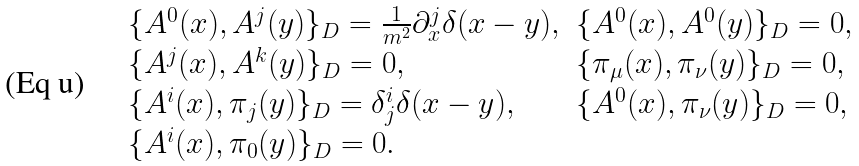<formula> <loc_0><loc_0><loc_500><loc_500>\begin{array} { l l } \{ A ^ { 0 } ( x ) , A ^ { j } ( y ) \} _ { D } = \frac { 1 } { m ^ { 2 } } \partial _ { x } ^ { j } \delta ( x - y ) , & \{ A ^ { 0 } ( x ) , A ^ { 0 } ( y ) \} _ { D } = 0 , \\ \{ A ^ { j } ( x ) , A ^ { k } ( y ) \} _ { D } = 0 , & \{ \pi _ { \mu } ( x ) , \pi _ { \nu } ( y ) \} _ { D } = 0 , \\ \{ A ^ { i } ( x ) , \pi _ { j } ( y ) \} _ { D } = \delta ^ { i } _ { j } \delta ( x - y ) , & \{ A ^ { 0 } ( x ) , \pi _ { \nu } ( y ) \} _ { D } = 0 , \\ \{ A ^ { i } ( x ) , \pi _ { 0 } ( y ) \} _ { D } = 0 . & \\ \end{array}</formula> 